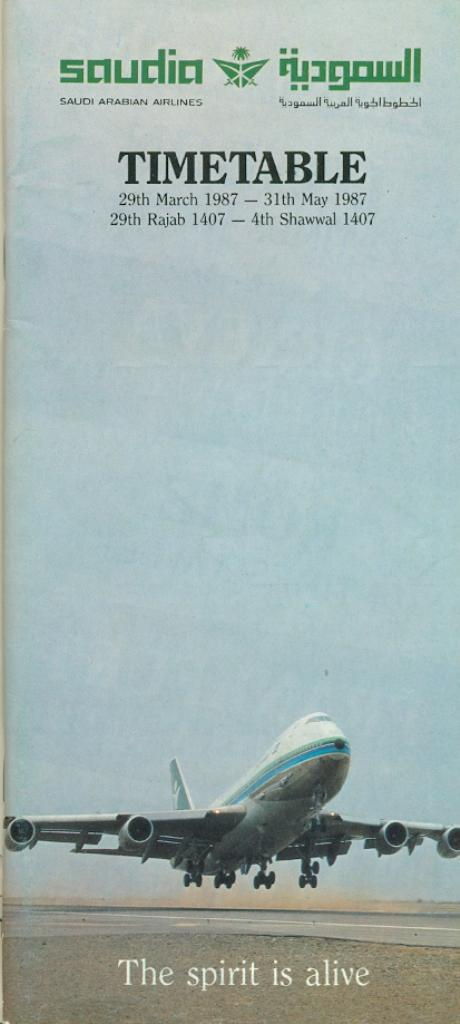What is featured on the poster in the image? The poster contains an image of an airplane. What else can be seen on the poster besides the airplane? There is text on the poster. What is visible in the background of the image? The sky is visible in the image. What type of insect can be seen crawling on the poster in the image? There are no insects present on the poster in the image. What is your opinion on the poster's design in the image? The conversation does not include any opinions, as it is focused on describing the image based on the provided facts. 